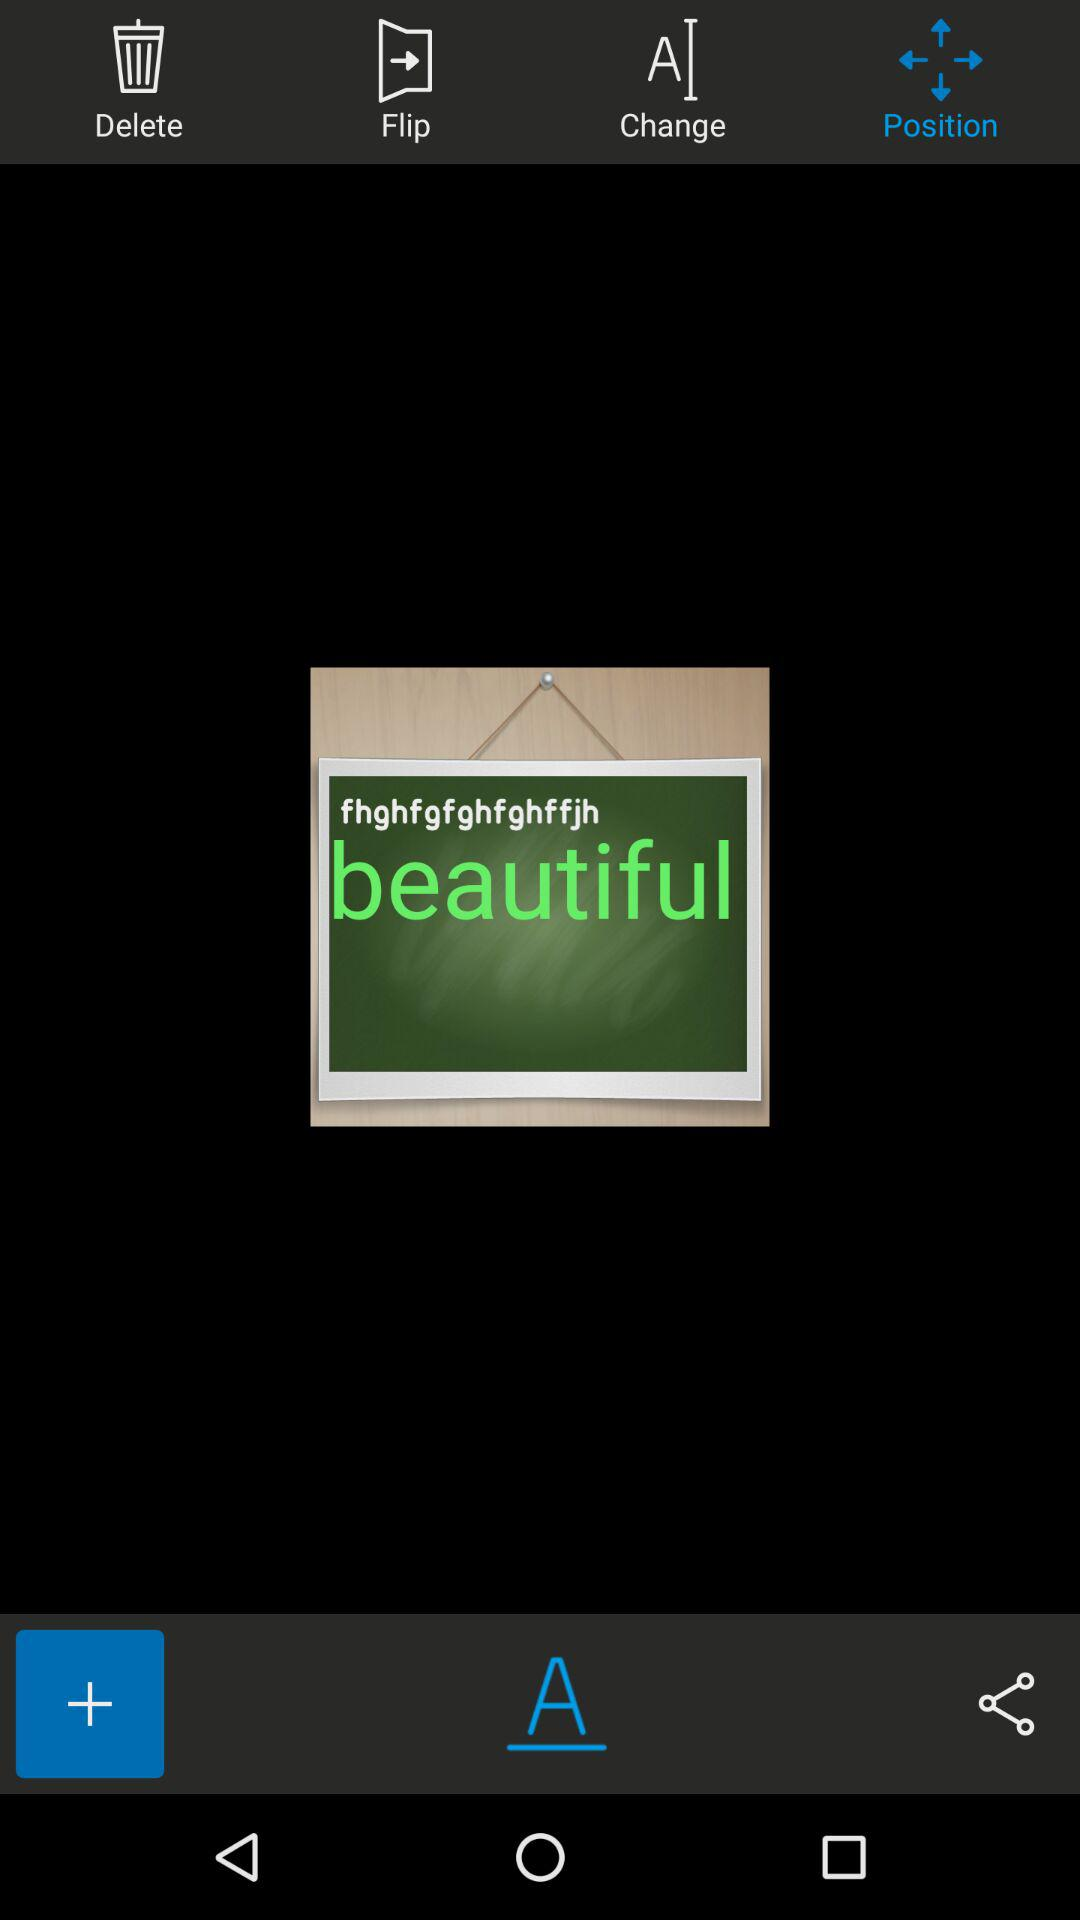Which tab is selected? The selected tab is "Position". 